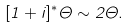<formula> <loc_0><loc_0><loc_500><loc_500>[ 1 + i ] ^ { * } \Theta \sim 2 \Theta .</formula> 